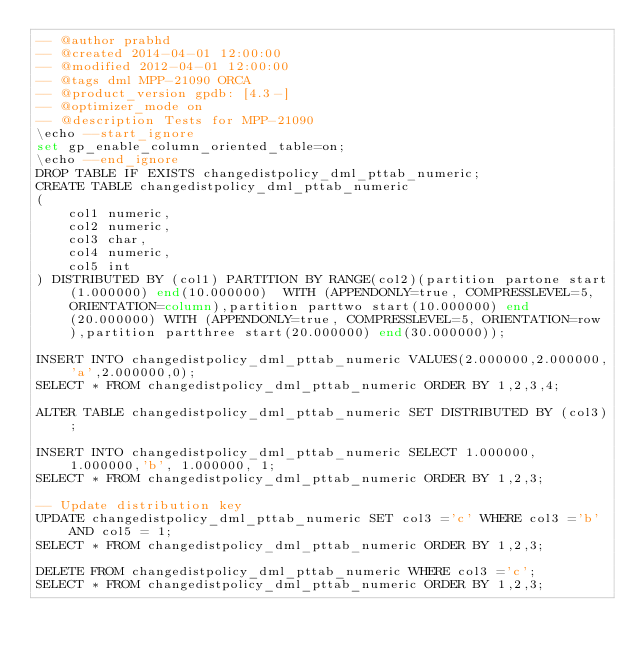Convert code to text. <code><loc_0><loc_0><loc_500><loc_500><_SQL_>-- @author prabhd 
-- @created 2014-04-01 12:00:00
-- @modified 2012-04-01 12:00:00
-- @tags dml MPP-21090 ORCA
-- @product_version gpdb: [4.3-]
-- @optimizer_mode on	
-- @description Tests for MPP-21090
\echo --start_ignore
set gp_enable_column_oriented_table=on;
\echo --end_ignore
DROP TABLE IF EXISTS changedistpolicy_dml_pttab_numeric;
CREATE TABLE changedistpolicy_dml_pttab_numeric
(
    col1 numeric,
    col2 numeric,
    col3 char,
    col4 numeric,
    col5 int
) DISTRIBUTED BY (col1) PARTITION BY RANGE(col2)(partition partone start(1.000000) end(10.000000)  WITH (APPENDONLY=true, COMPRESSLEVEL=5, ORIENTATION=column),partition parttwo start(10.000000) end(20.000000) WITH (APPENDONLY=true, COMPRESSLEVEL=5, ORIENTATION=row),partition partthree start(20.000000) end(30.000000));

INSERT INTO changedistpolicy_dml_pttab_numeric VALUES(2.000000,2.000000,'a',2.000000,0);
SELECT * FROM changedistpolicy_dml_pttab_numeric ORDER BY 1,2,3,4;

ALTER TABLE changedistpolicy_dml_pttab_numeric SET DISTRIBUTED BY (col3);

INSERT INTO changedistpolicy_dml_pttab_numeric SELECT 1.000000, 1.000000,'b', 1.000000, 1;
SELECT * FROM changedistpolicy_dml_pttab_numeric ORDER BY 1,2,3;

-- Update distribution key
UPDATE changedistpolicy_dml_pttab_numeric SET col3 ='c' WHERE col3 ='b' AND col5 = 1;
SELECT * FROM changedistpolicy_dml_pttab_numeric ORDER BY 1,2,3;

DELETE FROM changedistpolicy_dml_pttab_numeric WHERE col3 ='c';
SELECT * FROM changedistpolicy_dml_pttab_numeric ORDER BY 1,2,3;

</code> 